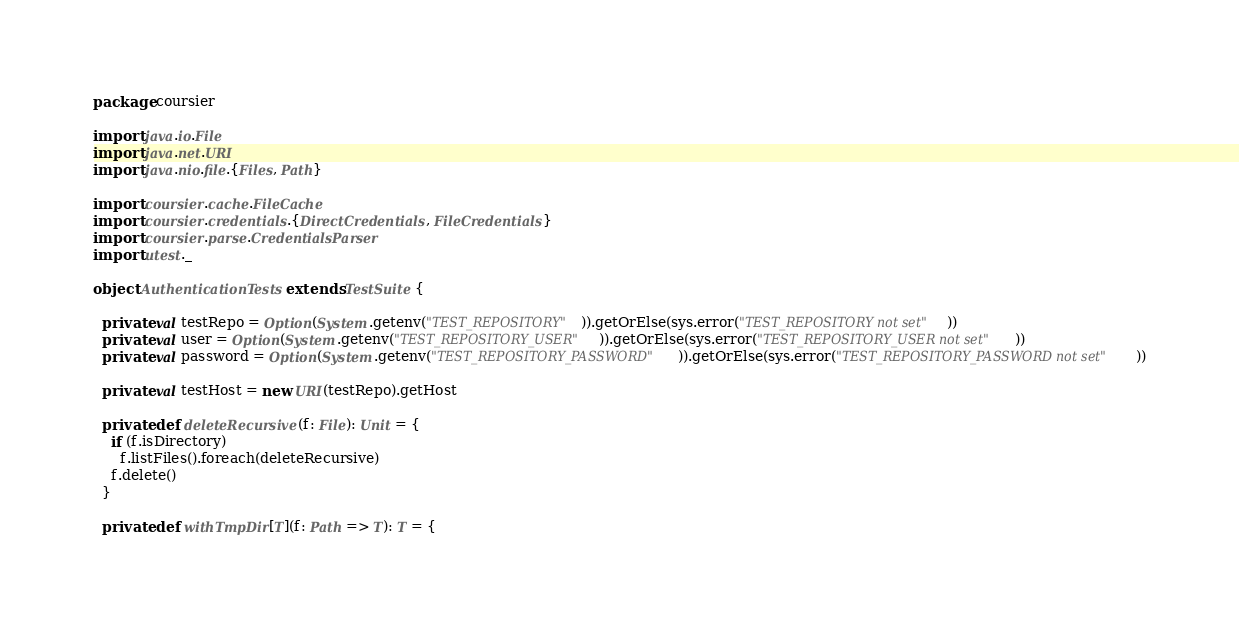<code> <loc_0><loc_0><loc_500><loc_500><_Scala_>package coursier

import java.io.File
import java.net.URI
import java.nio.file.{Files, Path}

import coursier.cache.FileCache
import coursier.credentials.{DirectCredentials, FileCredentials}
import coursier.parse.CredentialsParser
import utest._

object AuthenticationTests extends TestSuite {

  private val testRepo = Option(System.getenv("TEST_REPOSITORY")).getOrElse(sys.error("TEST_REPOSITORY not set"))
  private val user = Option(System.getenv("TEST_REPOSITORY_USER")).getOrElse(sys.error("TEST_REPOSITORY_USER not set"))
  private val password = Option(System.getenv("TEST_REPOSITORY_PASSWORD")).getOrElse(sys.error("TEST_REPOSITORY_PASSWORD not set"))

  private val testHost = new URI(testRepo).getHost

  private def deleteRecursive(f: File): Unit = {
    if (f.isDirectory)
      f.listFiles().foreach(deleteRecursive)
    f.delete()
  }

  private def withTmpDir[T](f: Path => T): T = {</code> 